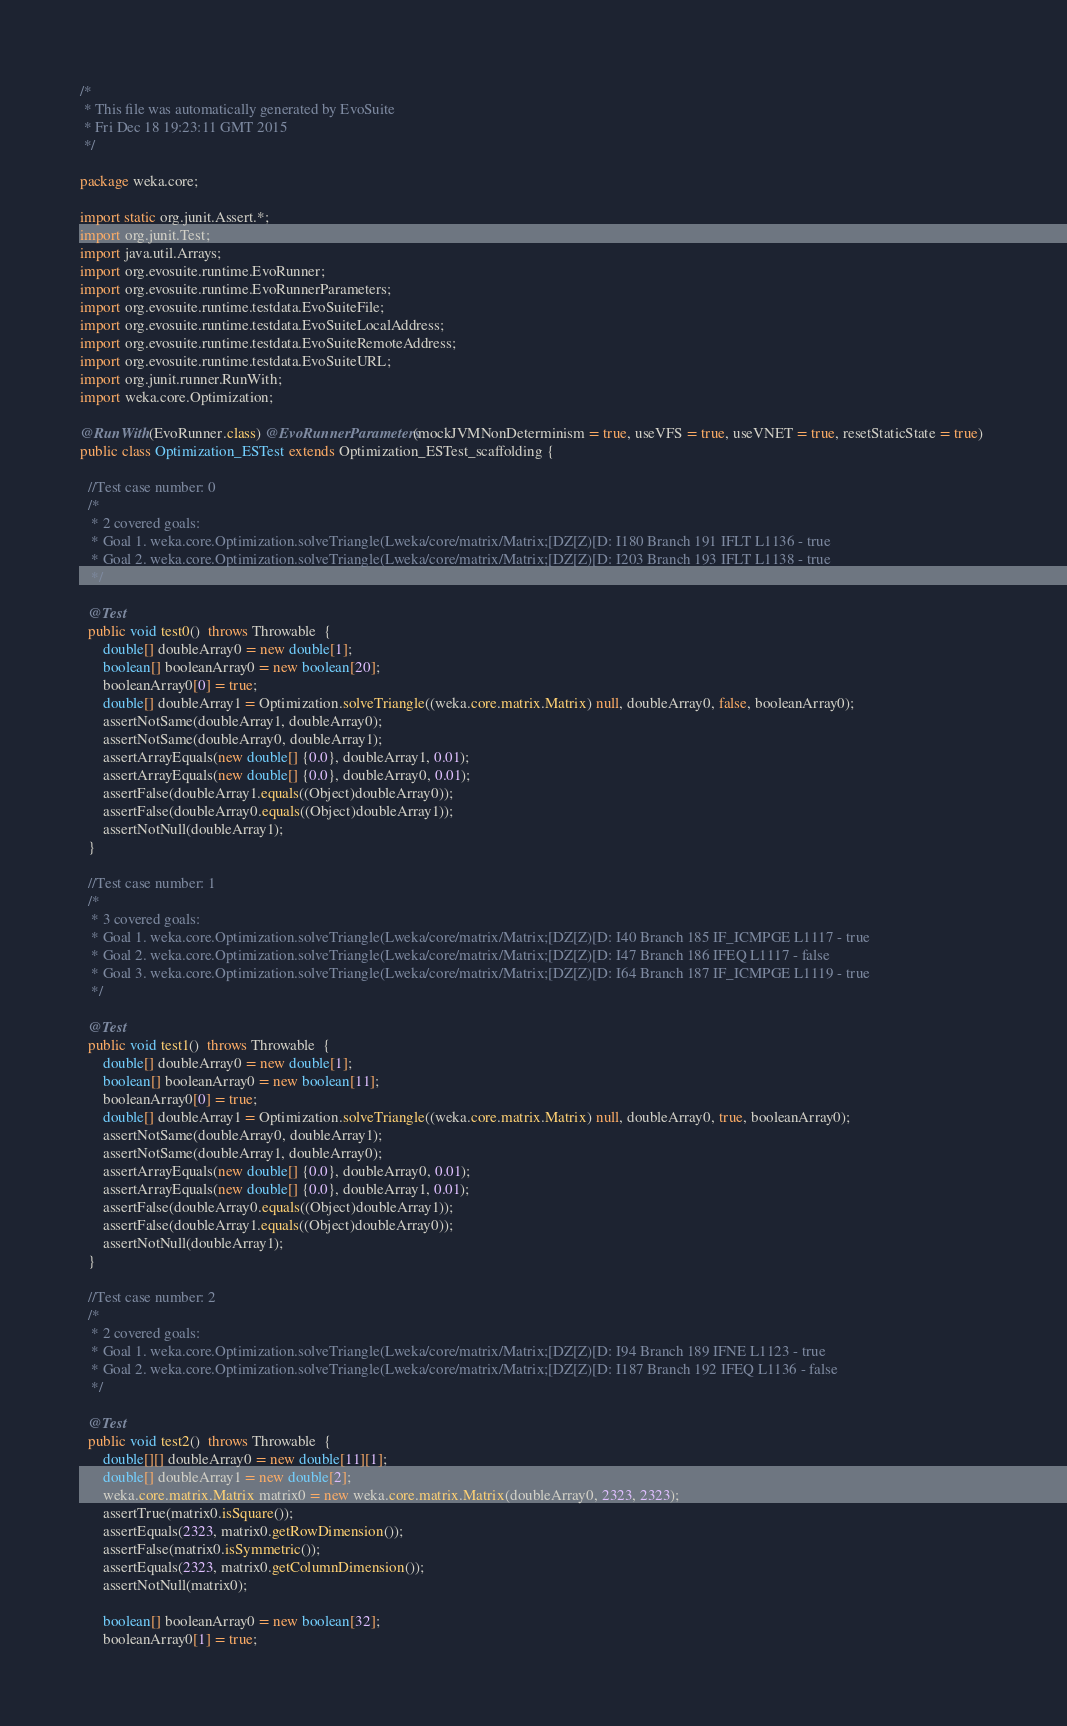Convert code to text. <code><loc_0><loc_0><loc_500><loc_500><_Java_>/*
 * This file was automatically generated by EvoSuite
 * Fri Dec 18 19:23:11 GMT 2015
 */

package weka.core;

import static org.junit.Assert.*;
import org.junit.Test;
import java.util.Arrays;
import org.evosuite.runtime.EvoRunner;
import org.evosuite.runtime.EvoRunnerParameters;
import org.evosuite.runtime.testdata.EvoSuiteFile;
import org.evosuite.runtime.testdata.EvoSuiteLocalAddress;
import org.evosuite.runtime.testdata.EvoSuiteRemoteAddress;
import org.evosuite.runtime.testdata.EvoSuiteURL;
import org.junit.runner.RunWith;
import weka.core.Optimization;

@RunWith(EvoRunner.class) @EvoRunnerParameters(mockJVMNonDeterminism = true, useVFS = true, useVNET = true, resetStaticState = true) 
public class Optimization_ESTest extends Optimization_ESTest_scaffolding {

  //Test case number: 0
  /*
   * 2 covered goals:
   * Goal 1. weka.core.Optimization.solveTriangle(Lweka/core/matrix/Matrix;[DZ[Z)[D: I180 Branch 191 IFLT L1136 - true
   * Goal 2. weka.core.Optimization.solveTriangle(Lweka/core/matrix/Matrix;[DZ[Z)[D: I203 Branch 193 IFLT L1138 - true
   */

  @Test
  public void test0()  throws Throwable  {
      double[] doubleArray0 = new double[1];
      boolean[] booleanArray0 = new boolean[20];
      booleanArray0[0] = true;
      double[] doubleArray1 = Optimization.solveTriangle((weka.core.matrix.Matrix) null, doubleArray0, false, booleanArray0);
      assertNotSame(doubleArray1, doubleArray0);
      assertNotSame(doubleArray0, doubleArray1);
      assertArrayEquals(new double[] {0.0}, doubleArray1, 0.01);
      assertArrayEquals(new double[] {0.0}, doubleArray0, 0.01);
      assertFalse(doubleArray1.equals((Object)doubleArray0));
      assertFalse(doubleArray0.equals((Object)doubleArray1));
      assertNotNull(doubleArray1);
  }

  //Test case number: 1
  /*
   * 3 covered goals:
   * Goal 1. weka.core.Optimization.solveTriangle(Lweka/core/matrix/Matrix;[DZ[Z)[D: I40 Branch 185 IF_ICMPGE L1117 - true
   * Goal 2. weka.core.Optimization.solveTriangle(Lweka/core/matrix/Matrix;[DZ[Z)[D: I47 Branch 186 IFEQ L1117 - false
   * Goal 3. weka.core.Optimization.solveTriangle(Lweka/core/matrix/Matrix;[DZ[Z)[D: I64 Branch 187 IF_ICMPGE L1119 - true
   */

  @Test
  public void test1()  throws Throwable  {
      double[] doubleArray0 = new double[1];
      boolean[] booleanArray0 = new boolean[11];
      booleanArray0[0] = true;
      double[] doubleArray1 = Optimization.solveTriangle((weka.core.matrix.Matrix) null, doubleArray0, true, booleanArray0);
      assertNotSame(doubleArray0, doubleArray1);
      assertNotSame(doubleArray1, doubleArray0);
      assertArrayEquals(new double[] {0.0}, doubleArray0, 0.01);
      assertArrayEquals(new double[] {0.0}, doubleArray1, 0.01);
      assertFalse(doubleArray0.equals((Object)doubleArray1));
      assertFalse(doubleArray1.equals((Object)doubleArray0));
      assertNotNull(doubleArray1);
  }

  //Test case number: 2
  /*
   * 2 covered goals:
   * Goal 1. weka.core.Optimization.solveTriangle(Lweka/core/matrix/Matrix;[DZ[Z)[D: I94 Branch 189 IFNE L1123 - true
   * Goal 2. weka.core.Optimization.solveTriangle(Lweka/core/matrix/Matrix;[DZ[Z)[D: I187 Branch 192 IFEQ L1136 - false
   */

  @Test
  public void test2()  throws Throwable  {
      double[][] doubleArray0 = new double[11][1];
      double[] doubleArray1 = new double[2];
      weka.core.matrix.Matrix matrix0 = new weka.core.matrix.Matrix(doubleArray0, 2323, 2323);
      assertTrue(matrix0.isSquare());
      assertEquals(2323, matrix0.getRowDimension());
      assertFalse(matrix0.isSymmetric());
      assertEquals(2323, matrix0.getColumnDimension());
      assertNotNull(matrix0);
      
      boolean[] booleanArray0 = new boolean[32];
      booleanArray0[1] = true;</code> 